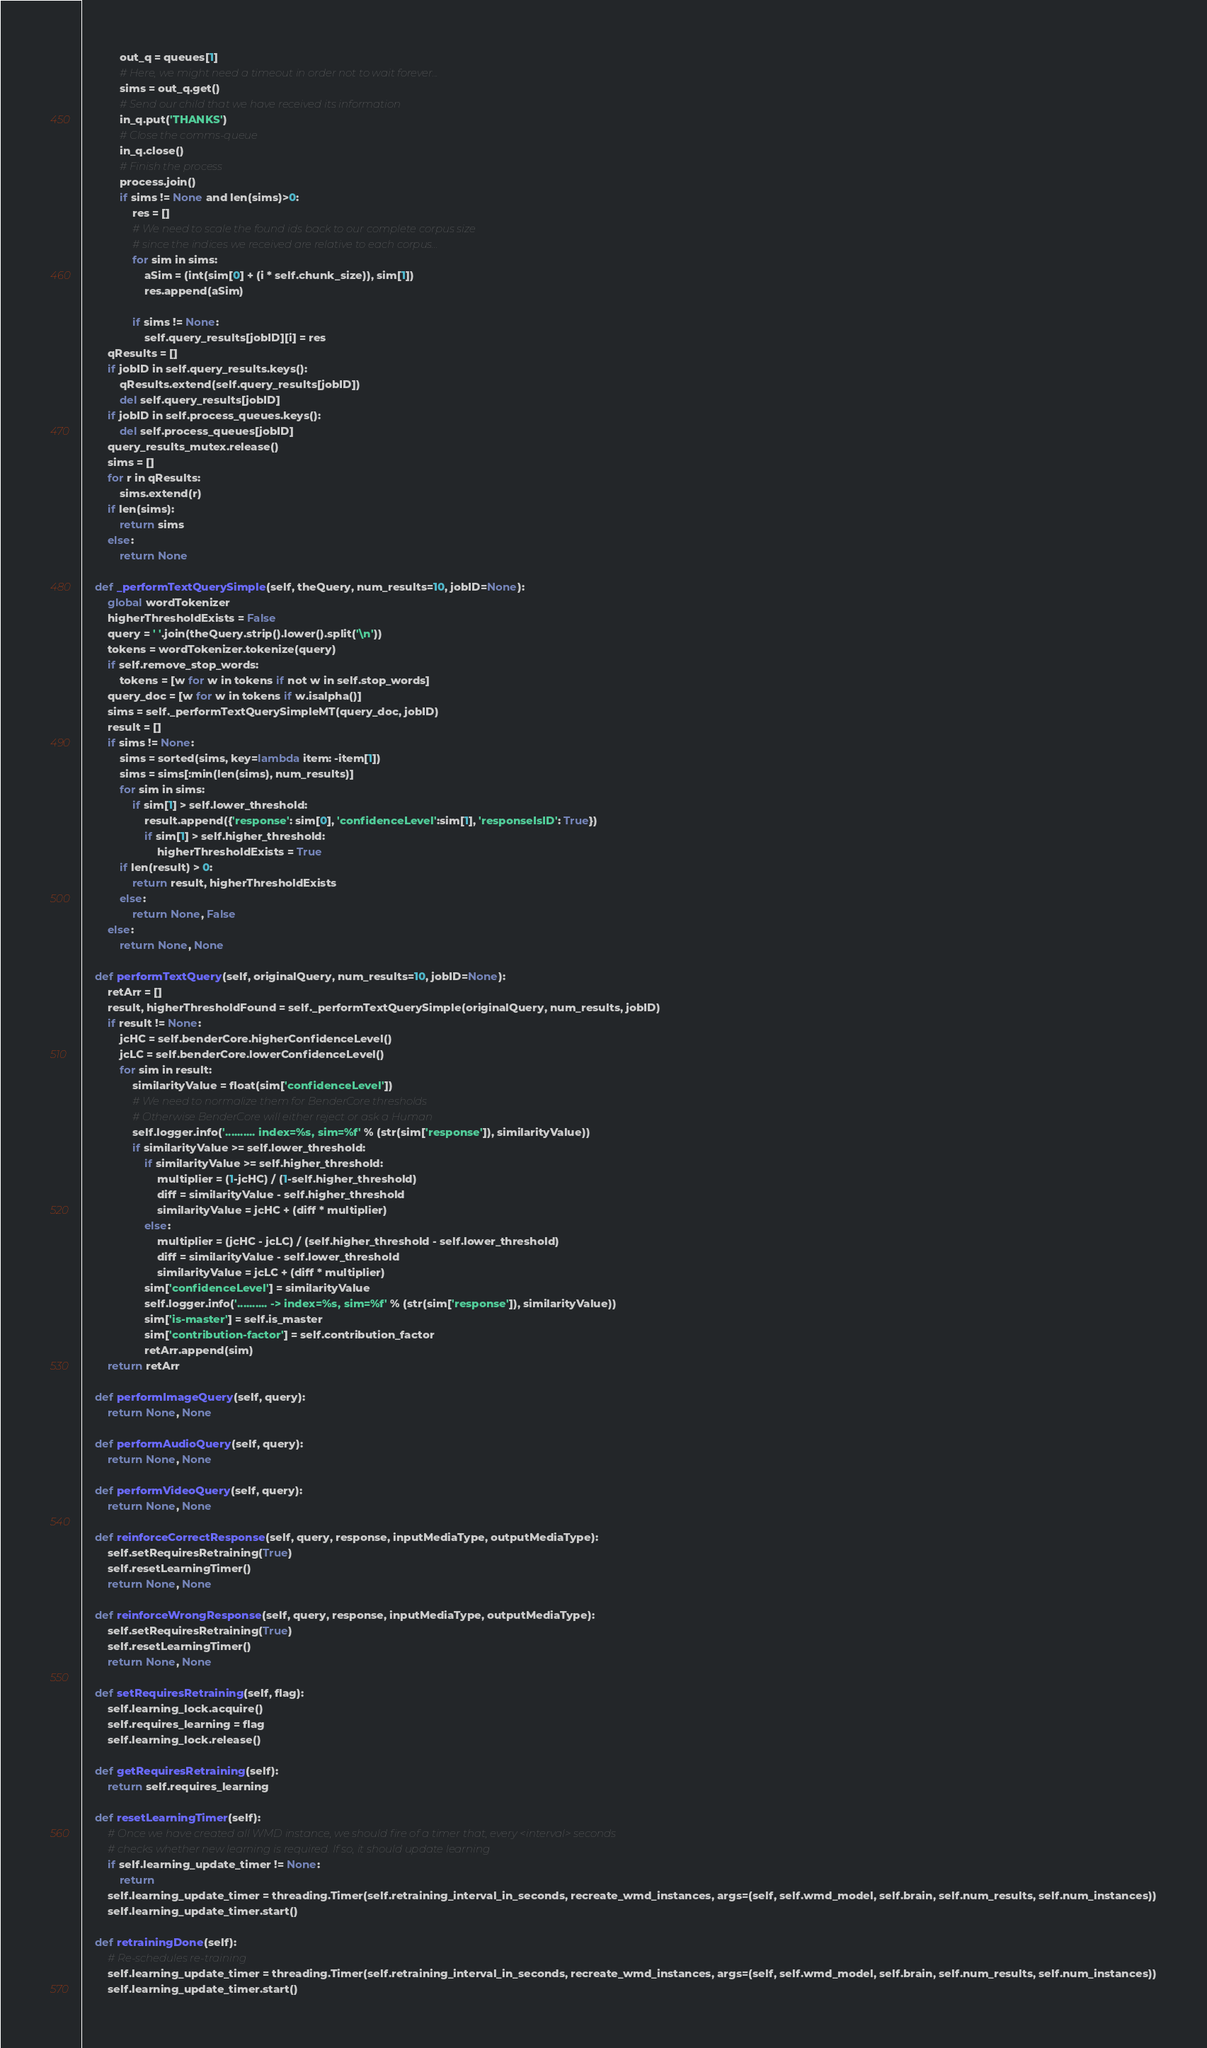Convert code to text. <code><loc_0><loc_0><loc_500><loc_500><_Python_>            out_q = queues[1]
            # Here, we might need a timeout in order not to wait forever...
            sims = out_q.get()
            # Send our child that we have received its information
            in_q.put('THANKS')
            # Close the comms-queue
            in_q.close()
            # Finish the process
            process.join()
            if sims != None and len(sims)>0:
                res = []
                # We need to scale the found ids back to our complete corpus size
                # since the indices we received are relative to each corpus...
                for sim in sims:
                    aSim = (int(sim[0] + (i * self.chunk_size)), sim[1])
                    res.append(aSim)

                if sims != None:
                    self.query_results[jobID][i] = res
        qResults = []
        if jobID in self.query_results.keys():
            qResults.extend(self.query_results[jobID])
            del self.query_results[jobID]
        if jobID in self.process_queues.keys():
            del self.process_queues[jobID]
        query_results_mutex.release()
        sims = []
        for r in qResults:
            sims.extend(r)
        if len(sims):
            return sims
        else:
            return None

    def _performTextQuerySimple(self, theQuery, num_results=10, jobID=None):
        global wordTokenizer
        higherThresholdExists = False
        query = ' '.join(theQuery.strip().lower().split('\n'))
        tokens = wordTokenizer.tokenize(query)
        if self.remove_stop_words:
            tokens = [w for w in tokens if not w in self.stop_words]
        query_doc = [w for w in tokens if w.isalpha()]
        sims = self._performTextQuerySimpleMT(query_doc, jobID)
        result = []
        if sims != None:
            sims = sorted(sims, key=lambda item: -item[1])
            sims = sims[:min(len(sims), num_results)]
            for sim in sims:
                if sim[1] > self.lower_threshold:
                    result.append({'response': sim[0], 'confidenceLevel':sim[1], 'responseIsID': True})
                    if sim[1] > self.higher_threshold:
                        higherThresholdExists = True
            if len(result) > 0:
                return result, higherThresholdExists
            else:
                return None, False
        else:
            return None, None
  
    def performTextQuery(self, originalQuery, num_results=10, jobID=None):
        retArr = []
        result, higherThresholdFound = self._performTextQuerySimple(originalQuery, num_results, jobID)
        if result != None:
            jcHC = self.benderCore.higherConfidenceLevel()
            jcLC = self.benderCore.lowerConfidenceLevel()
            for sim in result:
                similarityValue = float(sim['confidenceLevel'])
                # We need to normalize them for BenderCore thresholds
                # Otherwise BenderCore will either reject or ask a Human
                self.logger.info('.......... index=%s, sim=%f' % (str(sim['response']), similarityValue))
                if similarityValue >= self.lower_threshold:
                    if similarityValue >= self.higher_threshold:
                        multiplier = (1-jcHC) / (1-self.higher_threshold)
                        diff = similarityValue - self.higher_threshold
                        similarityValue = jcHC + (diff * multiplier)
                    else:
                        multiplier = (jcHC - jcLC) / (self.higher_threshold - self.lower_threshold)
                        diff = similarityValue - self.lower_threshold
                        similarityValue = jcLC + (diff * multiplier)
                    sim['confidenceLevel'] = similarityValue
                    self.logger.info('.......... -> index=%s, sim=%f' % (str(sim['response']), similarityValue))
                    sim['is-master'] = self.is_master
                    sim['contribution-factor'] = self.contribution_factor
                    retArr.append(sim)
        return retArr
  
    def performImageQuery(self, query):
        return None, None
  
    def performAudioQuery(self, query):
        return None, None
  
    def performVideoQuery(self, query):
        return None, None
  
    def reinforceCorrectResponse(self, query, response, inputMediaType, outputMediaType):
        self.setRequiresRetraining(True)
        self.resetLearningTimer()
        return None, None
  
    def reinforceWrongResponse(self, query, response, inputMediaType, outputMediaType):
        self.setRequiresRetraining(True)
        self.resetLearningTimer()
        return None, None
  
    def setRequiresRetraining(self, flag):
        self.learning_lock.acquire()
        self.requires_learning = flag
        self.learning_lock.release()

    def getRequiresRetraining(self):
        return self.requires_learning

    def resetLearningTimer(self):
        # Once we have created all WMD instance, we should fire of a timer that, every <interval> seconds
        # checks whether new learning is required. If so, it should update learning
        if self.learning_update_timer != None:
            return
        self.learning_update_timer = threading.Timer(self.retraining_interval_in_seconds, recreate_wmd_instances, args=(self, self.wmd_model, self.brain, self.num_results, self.num_instances))
        self.learning_update_timer.start()

    def retrainingDone(self):
        # Re-schedules re-training
        self.learning_update_timer = threading.Timer(self.retraining_interval_in_seconds, recreate_wmd_instances, args=(self, self.wmd_model, self.brain, self.num_results, self.num_instances))
        self.learning_update_timer.start()

</code> 